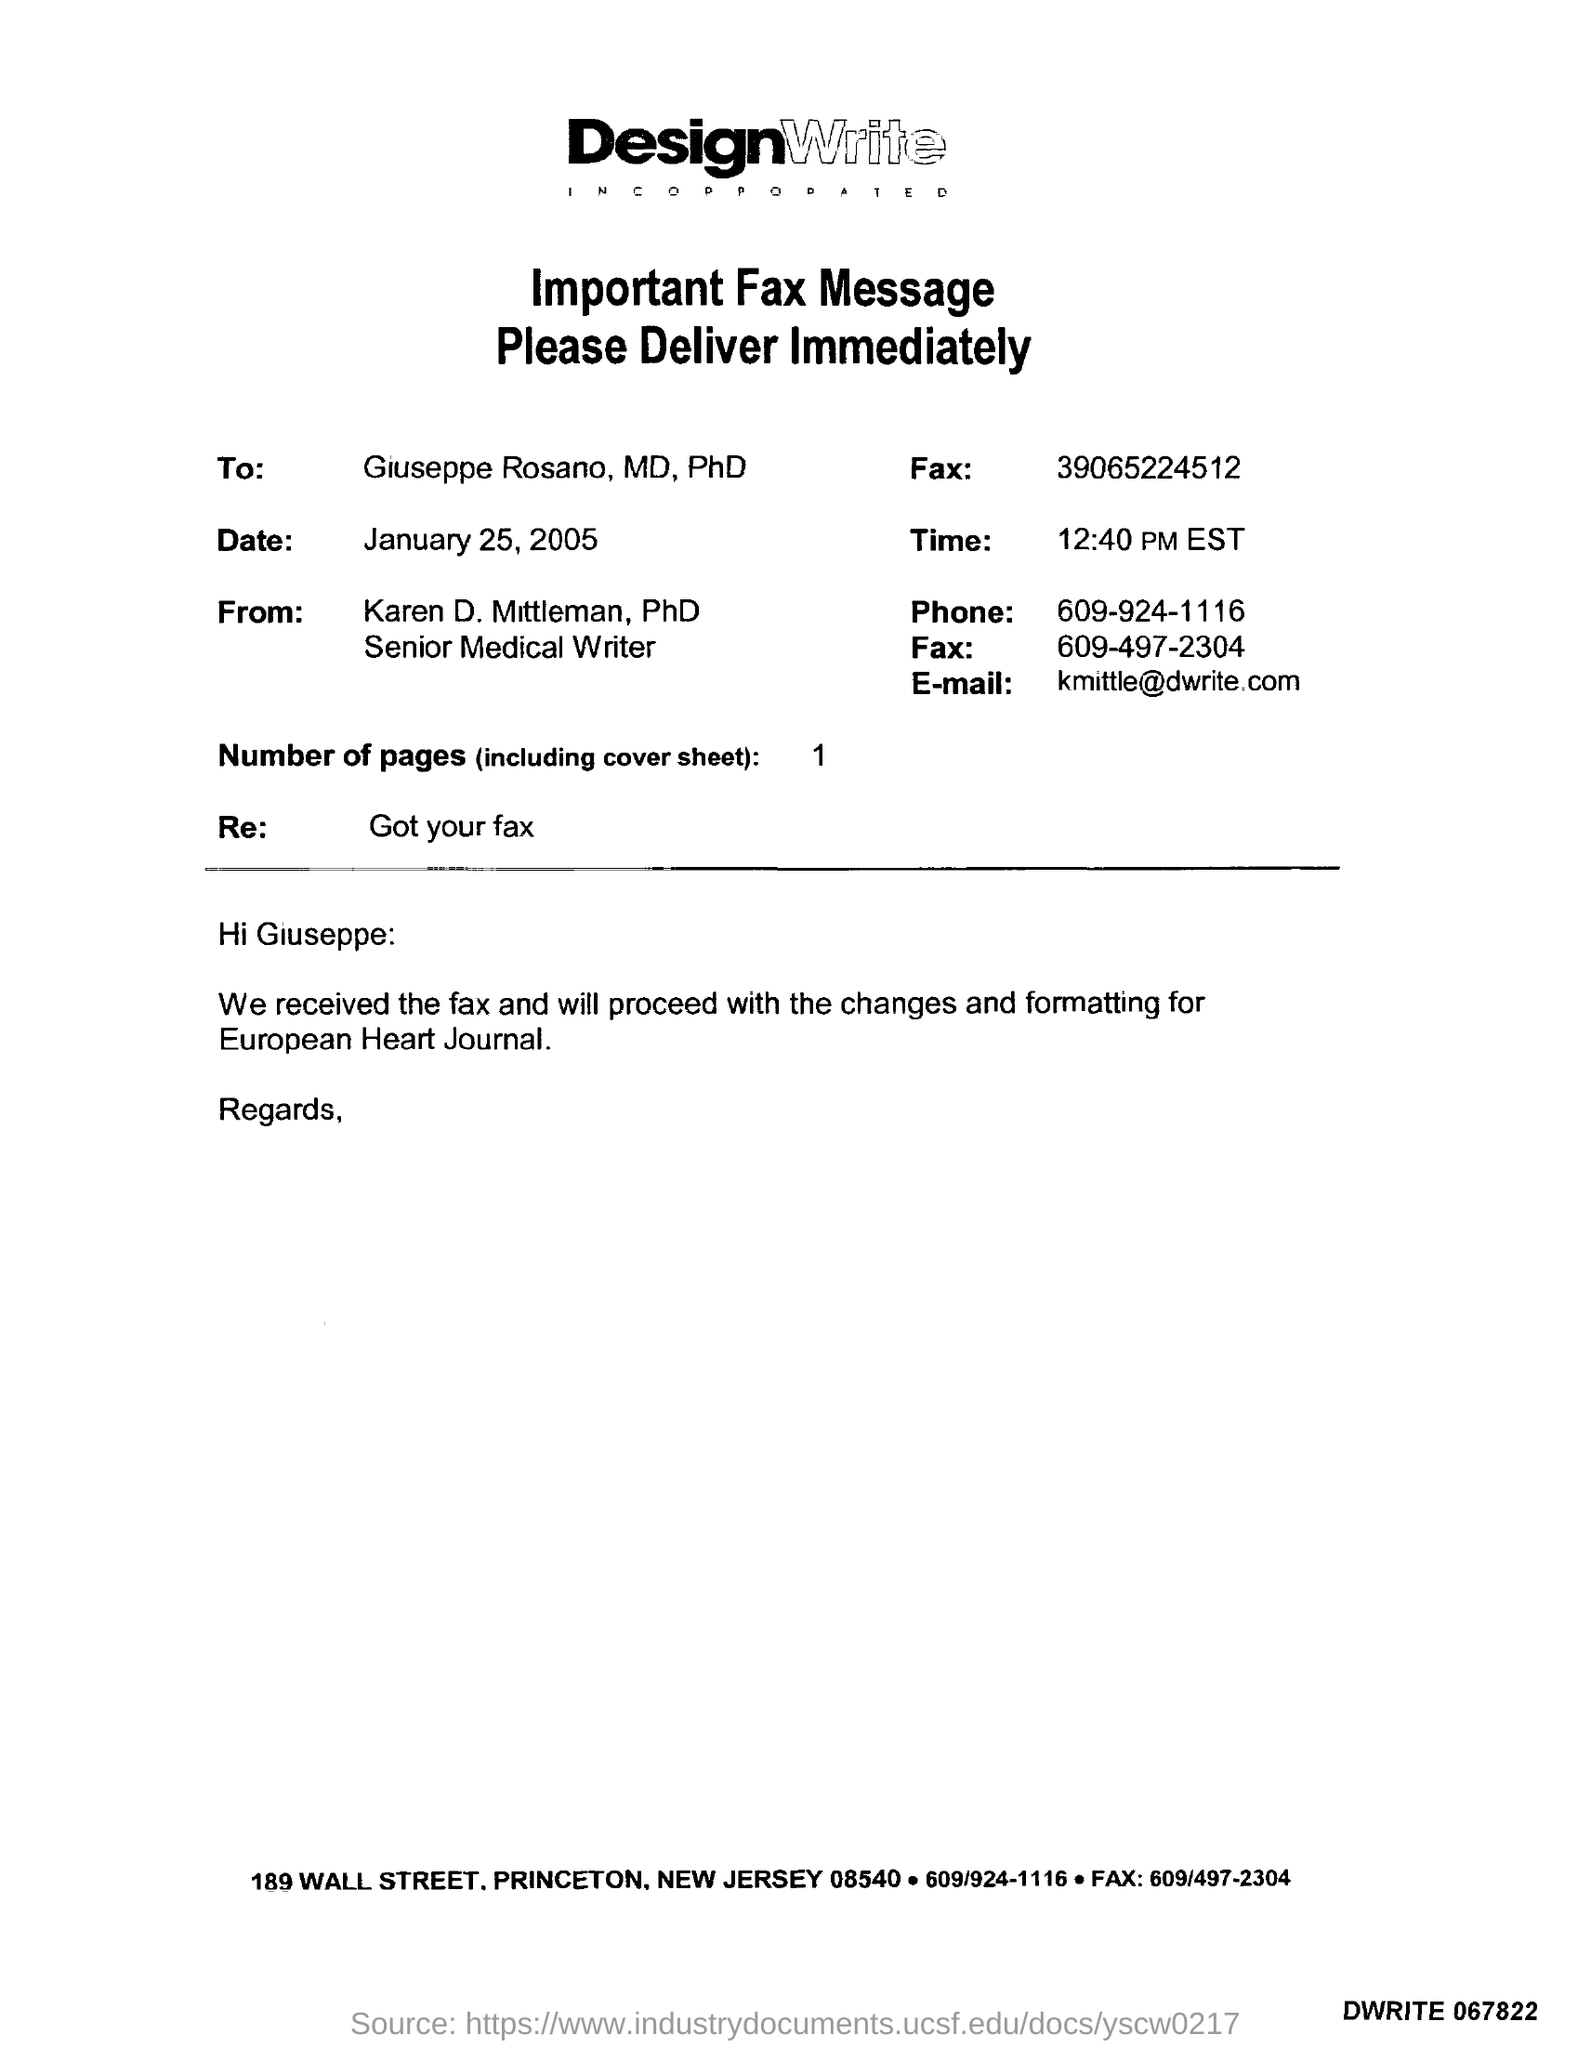Identify some key points in this picture. The phone number is 609/924-1116. The number of pages is 1.. The email address is kmittle@dwrite.com. 